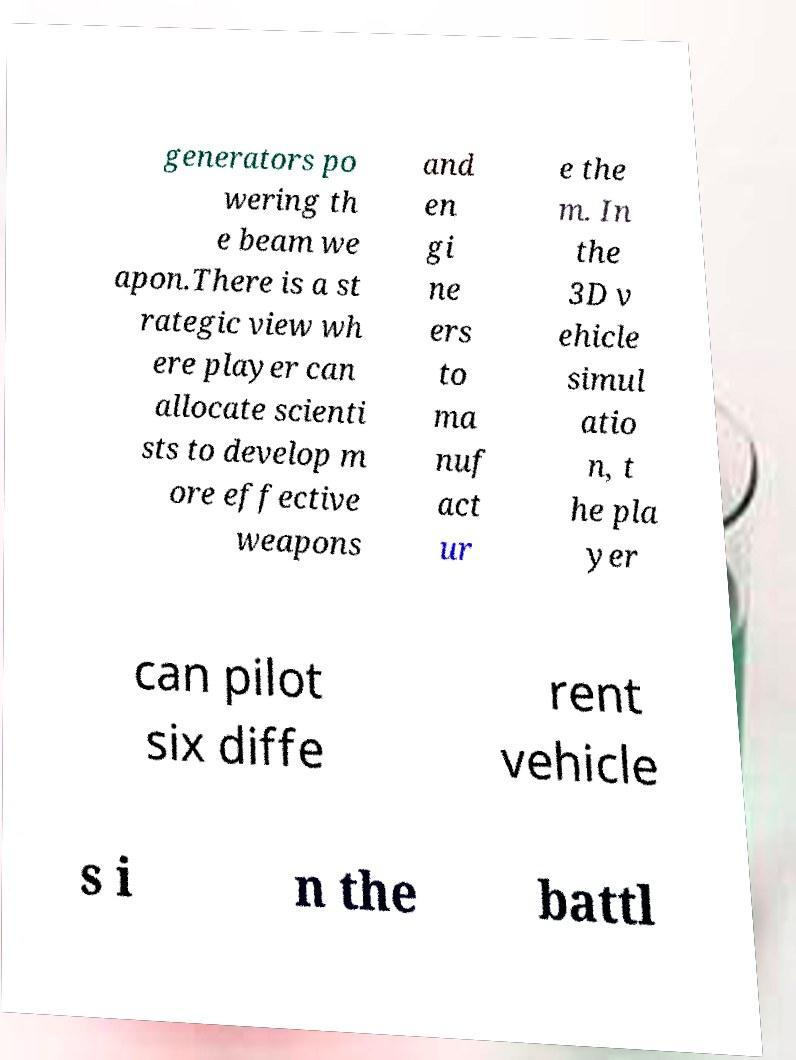Could you extract and type out the text from this image? generators po wering th e beam we apon.There is a st rategic view wh ere player can allocate scienti sts to develop m ore effective weapons and en gi ne ers to ma nuf act ur e the m. In the 3D v ehicle simul atio n, t he pla yer can pilot six diffe rent vehicle s i n the battl 